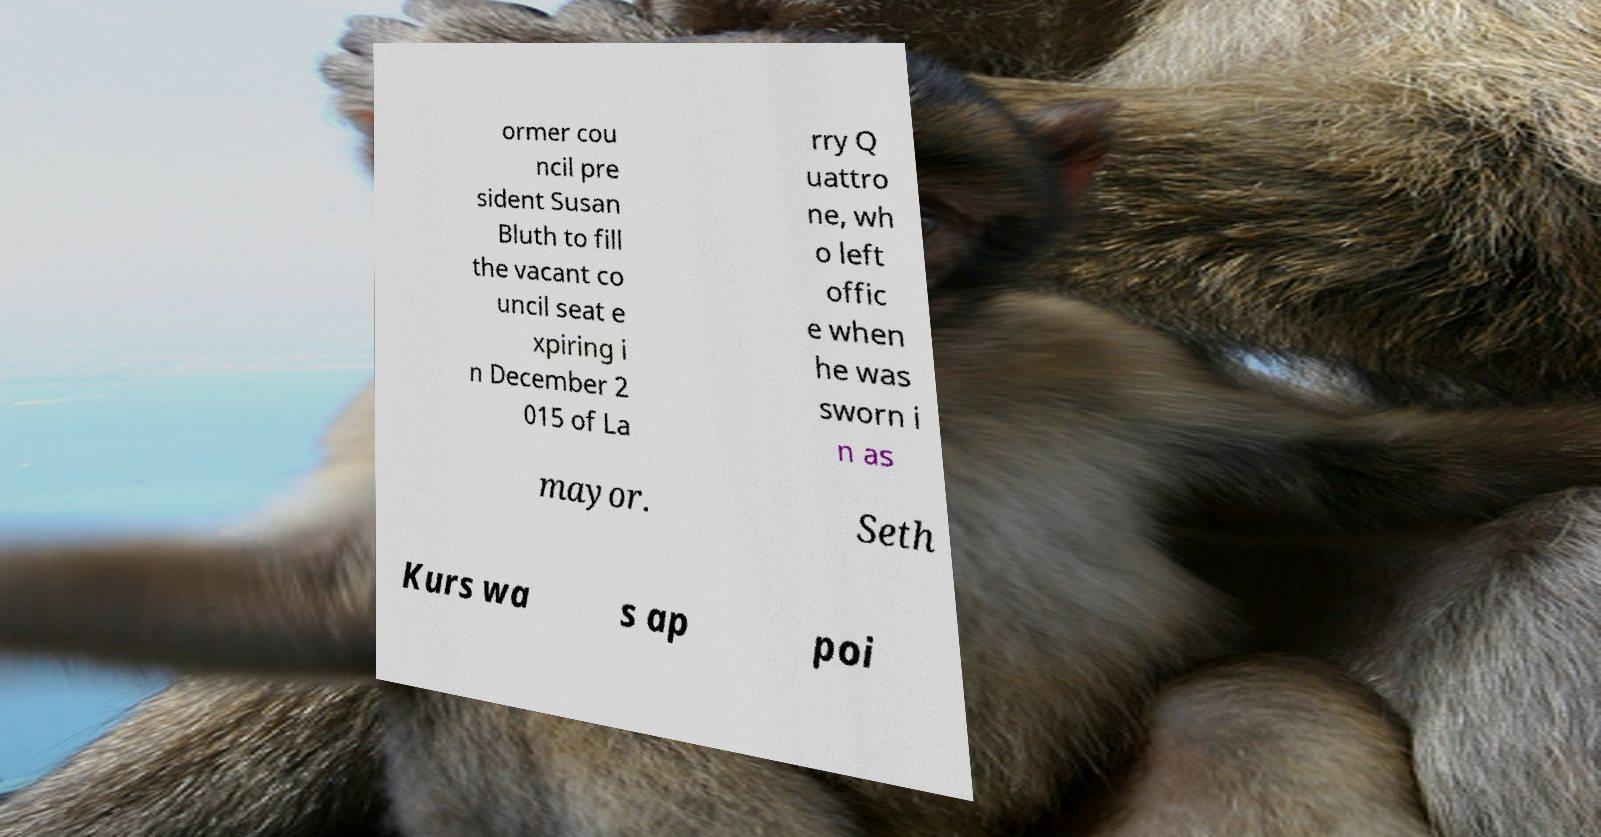There's text embedded in this image that I need extracted. Can you transcribe it verbatim? ormer cou ncil pre sident Susan Bluth to fill the vacant co uncil seat e xpiring i n December 2 015 of La rry Q uattro ne, wh o left offic e when he was sworn i n as mayor. Seth Kurs wa s ap poi 